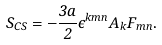Convert formula to latex. <formula><loc_0><loc_0><loc_500><loc_500>S _ { C S } = - \frac { 3 a } { 2 } \epsilon ^ { k m n } A _ { k } F _ { m n } .</formula> 